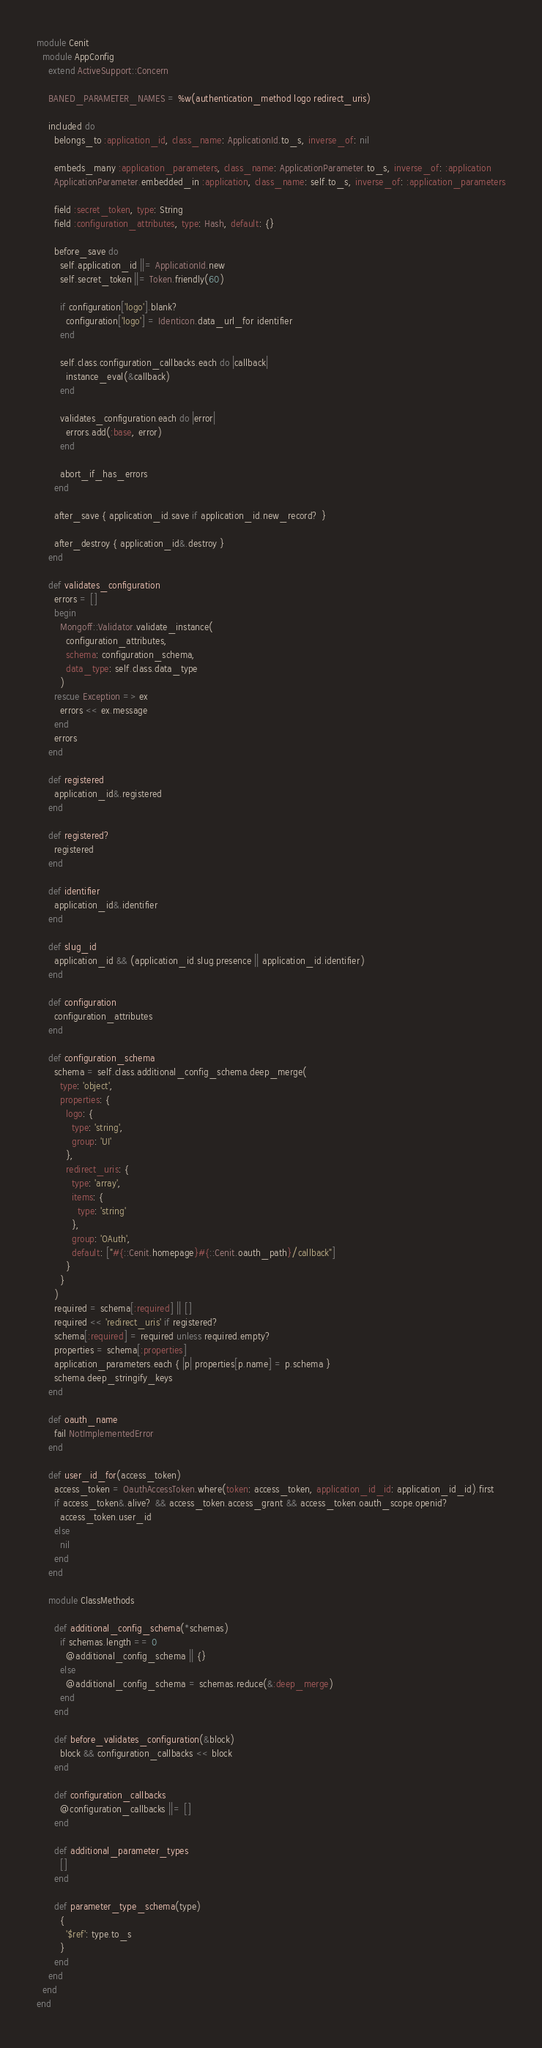<code> <loc_0><loc_0><loc_500><loc_500><_Ruby_>module Cenit
  module AppConfig
    extend ActiveSupport::Concern

    BANED_PARAMETER_NAMES = %w(authentication_method logo redirect_uris)

    included do
      belongs_to :application_id, class_name: ApplicationId.to_s, inverse_of: nil

      embeds_many :application_parameters, class_name: ApplicationParameter.to_s, inverse_of: :application
      ApplicationParameter.embedded_in :application, class_name: self.to_s, inverse_of: :application_parameters

      field :secret_token, type: String
      field :configuration_attributes, type: Hash, default: {}

      before_save do
        self.application_id ||= ApplicationId.new
        self.secret_token ||= Token.friendly(60)

        if configuration['logo'].blank?
          configuration['logo'] = Identicon.data_url_for identifier
        end

        self.class.configuration_callbacks.each do |callback|
          instance_eval(&callback)
        end

        validates_configuration.each do |error|
          errors.add(:base, error)
        end

        abort_if_has_errors
      end

      after_save { application_id.save if application_id.new_record? }

      after_destroy { application_id&.destroy }
    end

    def validates_configuration
      errors = []
      begin
        Mongoff::Validator.validate_instance(
          configuration_attributes,
          schema: configuration_schema,
          data_type: self.class.data_type
        )
      rescue Exception => ex
        errors << ex.message
      end
      errors
    end

    def registered
      application_id&.registered
    end

    def registered?
      registered
    end

    def identifier
      application_id&.identifier
    end

    def slug_id
      application_id && (application_id.slug.presence || application_id.identifier)
    end

    def configuration
      configuration_attributes
    end

    def configuration_schema
      schema = self.class.additional_config_schema.deep_merge(
        type: 'object',
        properties: {
          logo: {
            type: 'string',
            group: 'UI'
          },
          redirect_uris: {
            type: 'array',
            items: {
              type: 'string'
            },
            group: 'OAuth',
            default: ["#{::Cenit.homepage}#{::Cenit.oauth_path}/callback"]
          }
        }
      )
      required = schema[:required] || []
      required << 'redirect_uris' if registered?
      schema[:required] = required unless required.empty?
      properties = schema[:properties]
      application_parameters.each { |p| properties[p.name] = p.schema }
      schema.deep_stringify_keys
    end

    def oauth_name
      fail NotImplementedError
    end

    def user_id_for(access_token)
      access_token = OauthAccessToken.where(token: access_token, application_id_id: application_id_id).first
      if access_token&.alive? && access_token.access_grant && access_token.oauth_scope.openid?
        access_token.user_id
      else
        nil
      end
    end

    module ClassMethods

      def additional_config_schema(*schemas)
        if schemas.length == 0
          @additional_config_schema || {}
        else
          @additional_config_schema = schemas.reduce(&:deep_merge)
        end
      end

      def before_validates_configuration(&block)
        block && configuration_callbacks << block
      end

      def configuration_callbacks
        @configuration_callbacks ||= []
      end

      def additional_parameter_types
        []
      end

      def parameter_type_schema(type)
        {
          '$ref': type.to_s
        }
      end
    end
  end
end</code> 